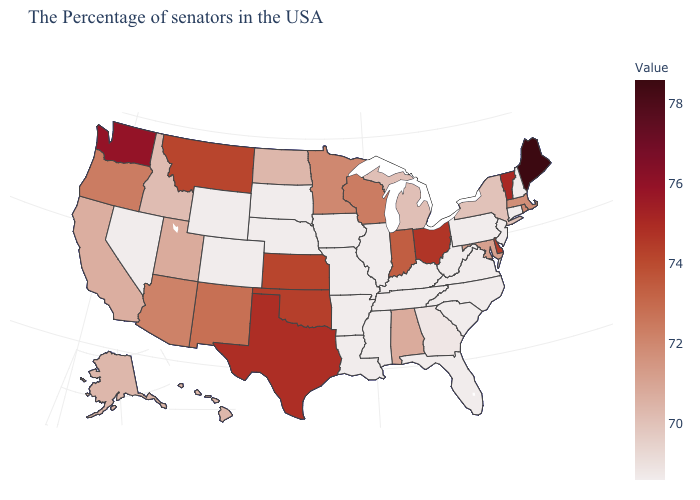Which states have the lowest value in the MidWest?
Answer briefly. Illinois, Missouri, Iowa, Nebraska, South Dakota. Does Massachusetts have the lowest value in the USA?
Short answer required. No. Which states have the lowest value in the USA?
Write a very short answer. New Hampshire, Connecticut, New Jersey, Pennsylvania, Virginia, North Carolina, South Carolina, West Virginia, Florida, Kentucky, Tennessee, Illinois, Mississippi, Louisiana, Missouri, Arkansas, Iowa, Nebraska, South Dakota, Wyoming, Colorado, Nevada. 